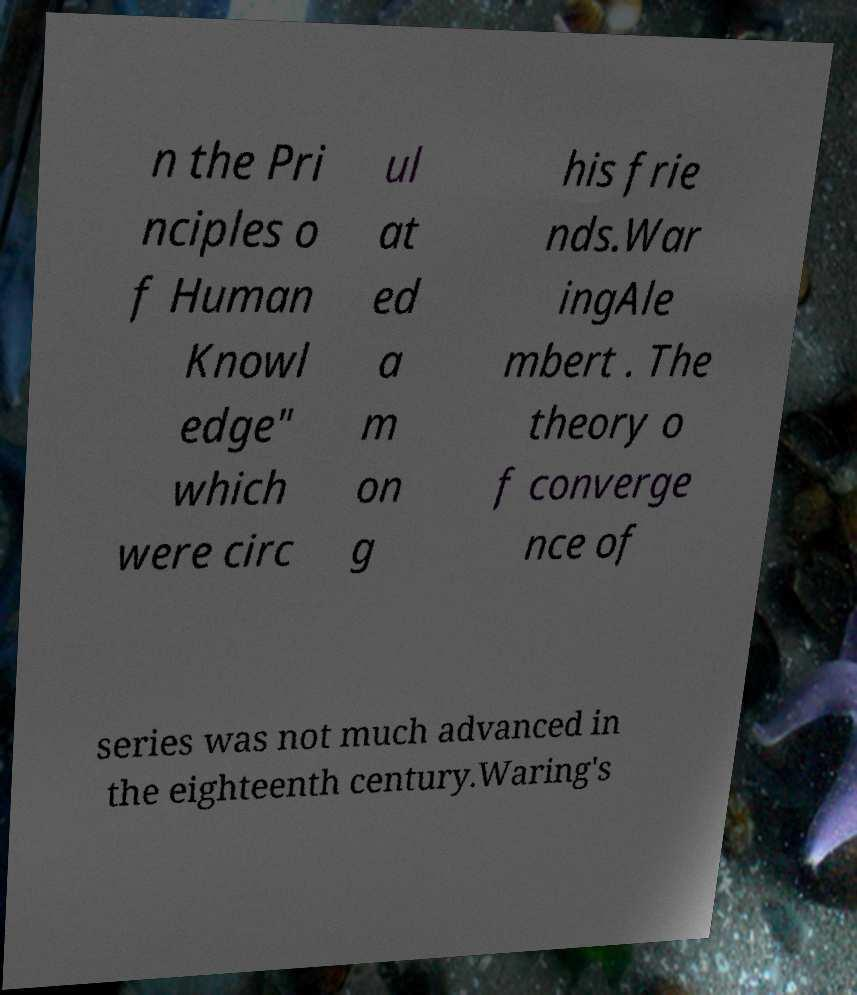What messages or text are displayed in this image? I need them in a readable, typed format. n the Pri nciples o f Human Knowl edge" which were circ ul at ed a m on g his frie nds.War ingAle mbert . The theory o f converge nce of series was not much advanced in the eighteenth century.Waring's 